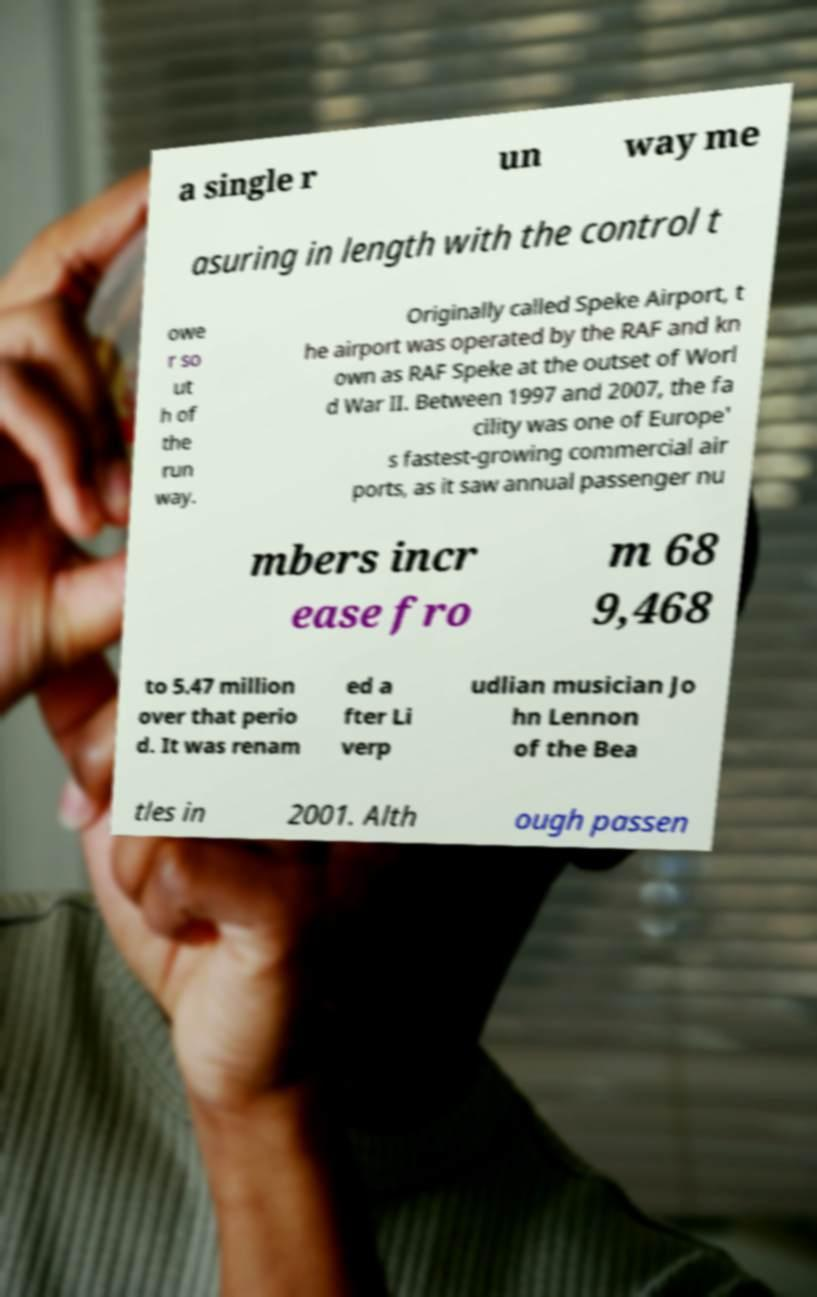There's text embedded in this image that I need extracted. Can you transcribe it verbatim? a single r un way me asuring in length with the control t owe r so ut h of the run way. Originally called Speke Airport, t he airport was operated by the RAF and kn own as RAF Speke at the outset of Worl d War II. Between 1997 and 2007, the fa cility was one of Europe' s fastest-growing commercial air ports, as it saw annual passenger nu mbers incr ease fro m 68 9,468 to 5.47 million over that perio d. It was renam ed a fter Li verp udlian musician Jo hn Lennon of the Bea tles in 2001. Alth ough passen 